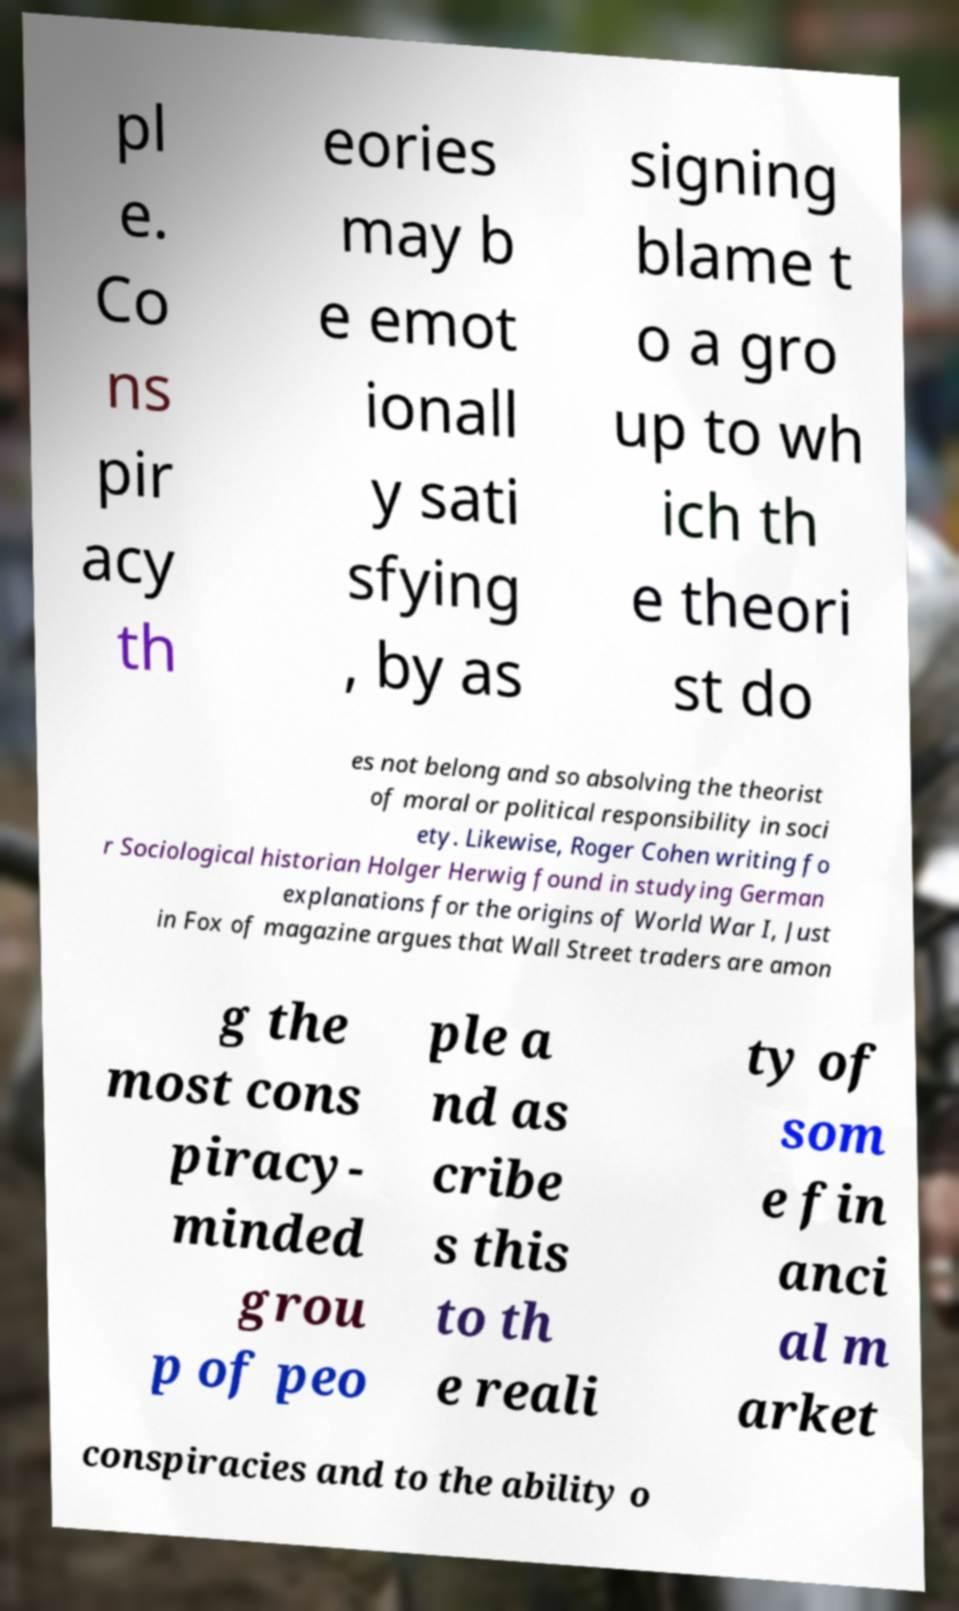I need the written content from this picture converted into text. Can you do that? pl e. Co ns pir acy th eories may b e emot ionall y sati sfying , by as signing blame t o a gro up to wh ich th e theori st do es not belong and so absolving the theorist of moral or political responsibility in soci ety. Likewise, Roger Cohen writing fo r Sociological historian Holger Herwig found in studying German explanations for the origins of World War I, Just in Fox of magazine argues that Wall Street traders are amon g the most cons piracy- minded grou p of peo ple a nd as cribe s this to th e reali ty of som e fin anci al m arket conspiracies and to the ability o 